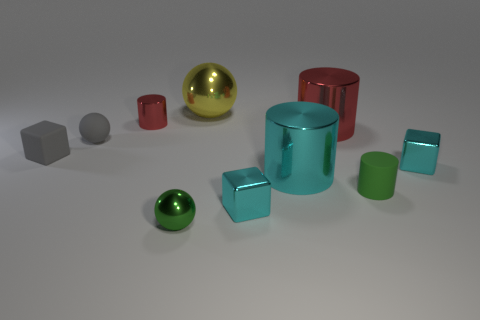There is a small thing behind the gray matte sphere; what material is it? metal 